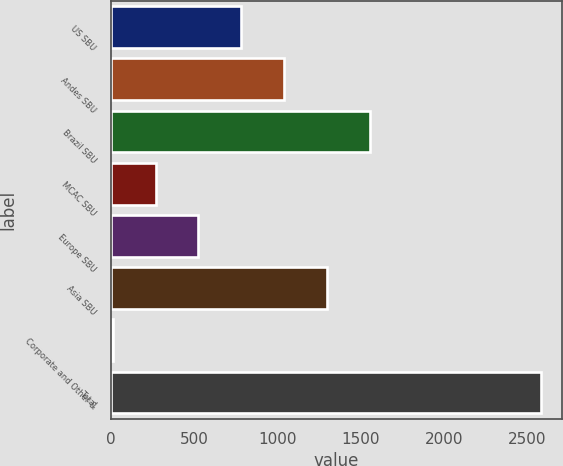Convert chart to OTSL. <chart><loc_0><loc_0><loc_500><loc_500><bar_chart><fcel>US SBU<fcel>Andes SBU<fcel>Brazil SBU<fcel>MCAC SBU<fcel>Europe SBU<fcel>Asia SBU<fcel>Corporate and Other &<fcel>Total<nl><fcel>783.5<fcel>1040<fcel>1553<fcel>270.5<fcel>527<fcel>1296.5<fcel>14<fcel>2579<nl></chart> 